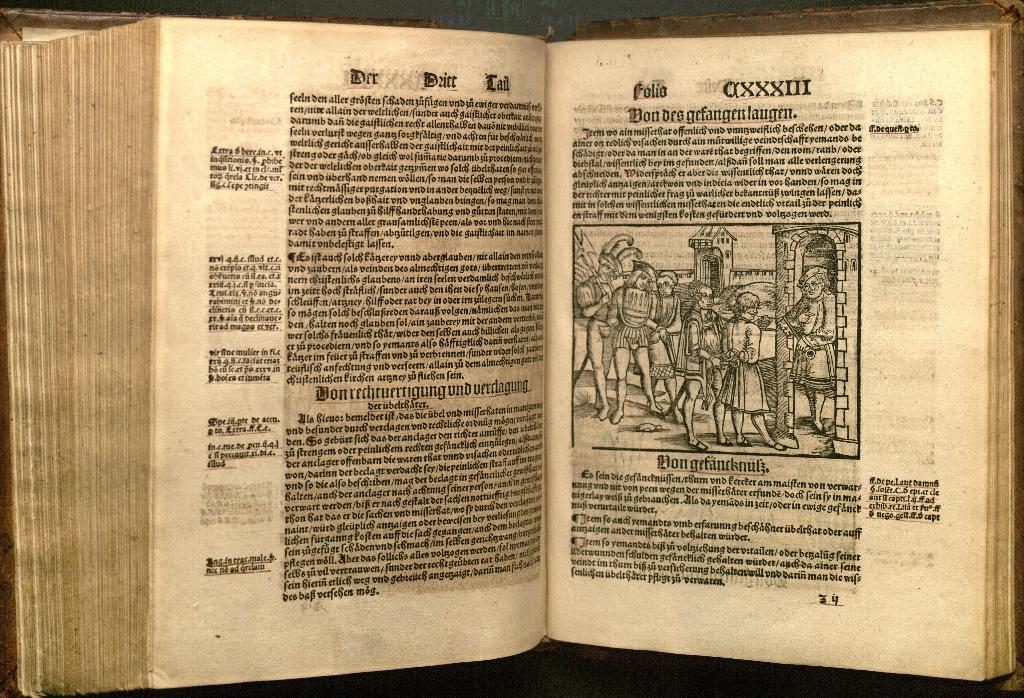What page number is the pages on?
Provide a succinct answer. 34. 